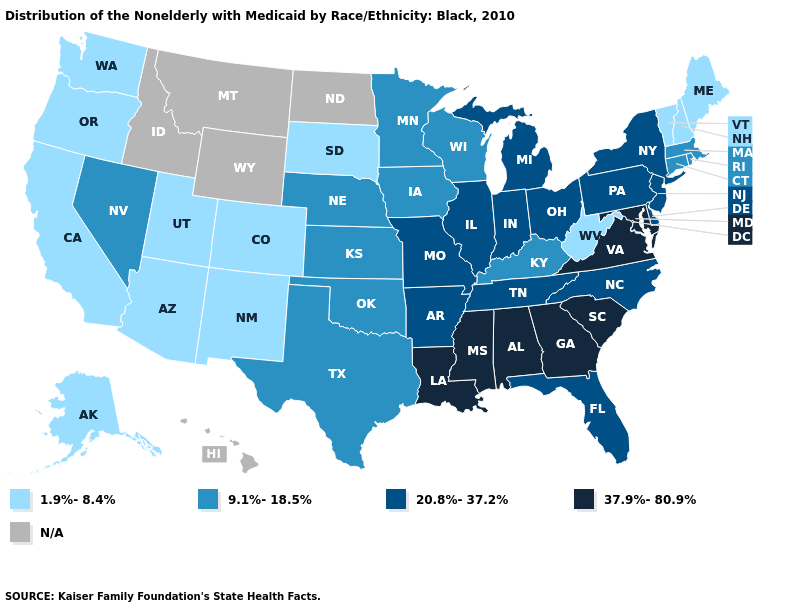Does Oregon have the lowest value in the West?
Keep it brief. Yes. Name the states that have a value in the range 1.9%-8.4%?
Keep it brief. Alaska, Arizona, California, Colorado, Maine, New Hampshire, New Mexico, Oregon, South Dakota, Utah, Vermont, Washington, West Virginia. Does the first symbol in the legend represent the smallest category?
Keep it brief. Yes. Name the states that have a value in the range 20.8%-37.2%?
Keep it brief. Arkansas, Delaware, Florida, Illinois, Indiana, Michigan, Missouri, New Jersey, New York, North Carolina, Ohio, Pennsylvania, Tennessee. What is the lowest value in states that border Utah?
Short answer required. 1.9%-8.4%. What is the value of New Mexico?
Short answer required. 1.9%-8.4%. Does the map have missing data?
Quick response, please. Yes. Which states have the highest value in the USA?
Answer briefly. Alabama, Georgia, Louisiana, Maryland, Mississippi, South Carolina, Virginia. What is the value of New Jersey?
Keep it brief. 20.8%-37.2%. Does Colorado have the highest value in the USA?
Answer briefly. No. Which states have the highest value in the USA?
Quick response, please. Alabama, Georgia, Louisiana, Maryland, Mississippi, South Carolina, Virginia. Name the states that have a value in the range 1.9%-8.4%?
Short answer required. Alaska, Arizona, California, Colorado, Maine, New Hampshire, New Mexico, Oregon, South Dakota, Utah, Vermont, Washington, West Virginia. Which states have the lowest value in the USA?
Be succinct. Alaska, Arizona, California, Colorado, Maine, New Hampshire, New Mexico, Oregon, South Dakota, Utah, Vermont, Washington, West Virginia. 